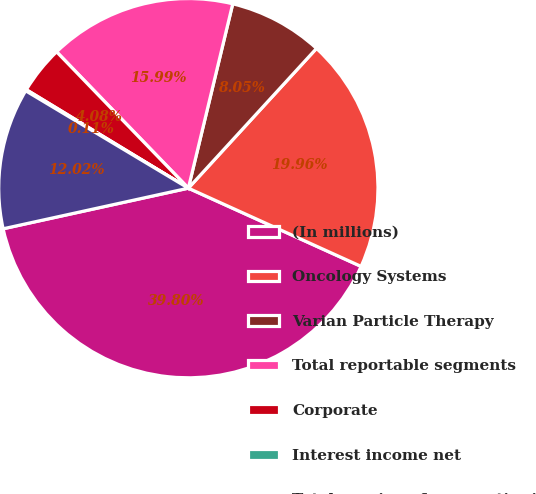<chart> <loc_0><loc_0><loc_500><loc_500><pie_chart><fcel>(In millions)<fcel>Oncology Systems<fcel>Varian Particle Therapy<fcel>Total reportable segments<fcel>Corporate<fcel>Interest income net<fcel>Total earnings from continuing<nl><fcel>39.8%<fcel>19.96%<fcel>8.05%<fcel>15.99%<fcel>4.08%<fcel>0.11%<fcel>12.02%<nl></chart> 